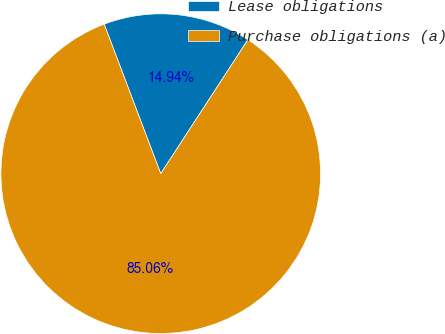Convert chart. <chart><loc_0><loc_0><loc_500><loc_500><pie_chart><fcel>Lease obligations<fcel>Purchase obligations (a)<nl><fcel>14.94%<fcel>85.06%<nl></chart> 